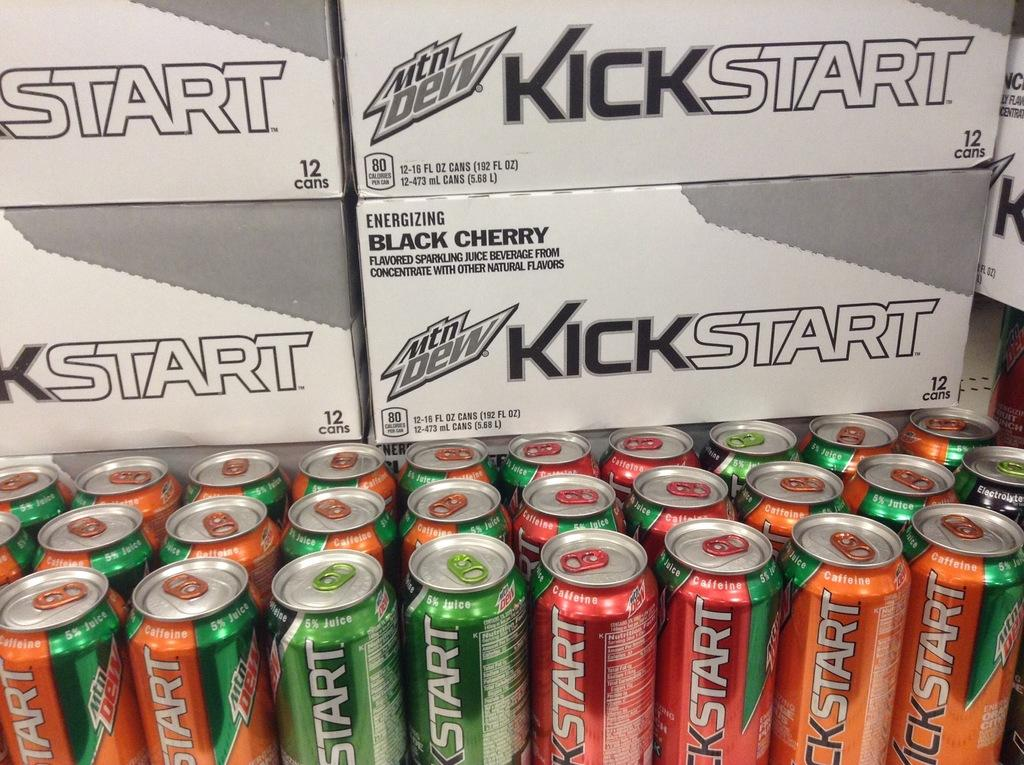<image>
Give a short and clear explanation of the subsequent image. A pallet of Kickstart energy drinks made by Mountain Dew. 